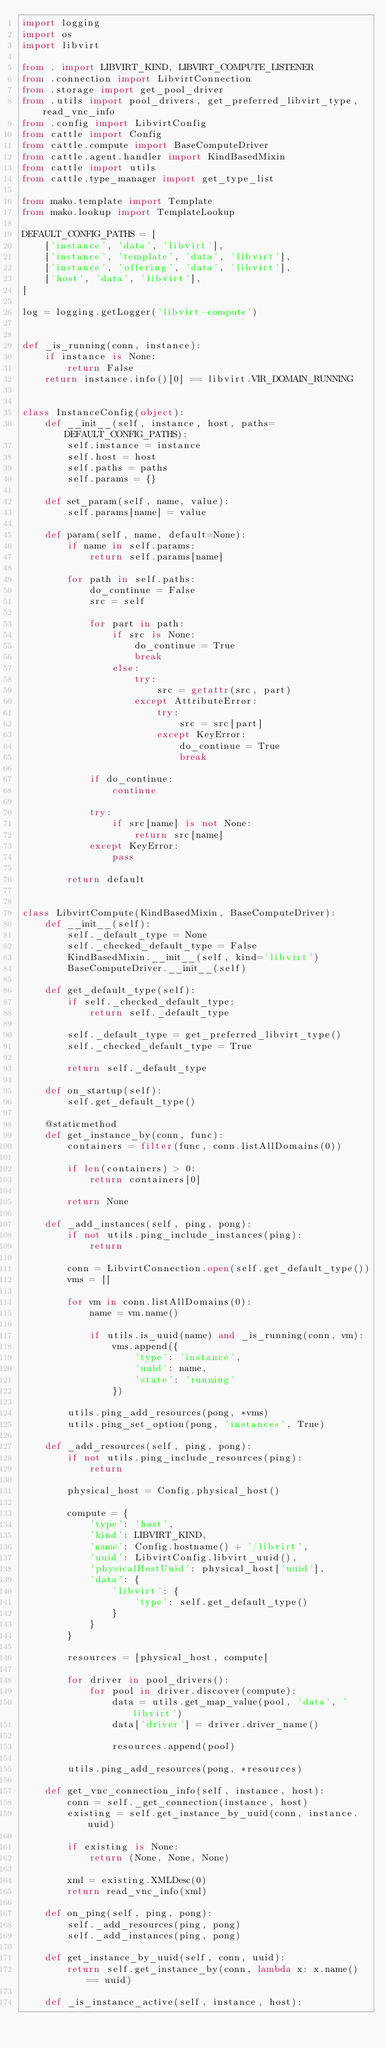<code> <loc_0><loc_0><loc_500><loc_500><_Python_>import logging
import os
import libvirt

from . import LIBVIRT_KIND, LIBVIRT_COMPUTE_LISTENER
from .connection import LibvirtConnection
from .storage import get_pool_driver
from .utils import pool_drivers, get_preferred_libvirt_type, read_vnc_info
from .config import LibvirtConfig
from cattle import Config
from cattle.compute import BaseComputeDriver
from cattle.agent.handler import KindBasedMixin
from cattle import utils
from cattle.type_manager import get_type_list

from mako.template import Template
from mako.lookup import TemplateLookup

DEFAULT_CONFIG_PATHS = [
    ['instance', 'data', 'libvirt'],
    ['instance', 'template', 'data', 'libvirt'],
    ['instance', 'offering', 'data', 'libvirt'],
    ['host', 'data', 'libvirt'],
]

log = logging.getLogger('libvirt-compute')


def _is_running(conn, instance):
    if instance is None:
        return False
    return instance.info()[0] == libvirt.VIR_DOMAIN_RUNNING


class InstanceConfig(object):
    def __init__(self, instance, host, paths=DEFAULT_CONFIG_PATHS):
        self.instance = instance
        self.host = host
        self.paths = paths
        self.params = {}

    def set_param(self, name, value):
        self.params[name] = value

    def param(self, name, default=None):
        if name in self.params:
            return self.params[name]

        for path in self.paths:
            do_continue = False
            src = self

            for part in path:
                if src is None:
                    do_continue = True
                    break
                else:
                    try:
                        src = getattr(src, part)
                    except AttributeError:
                        try:
                            src = src[part]
                        except KeyError:
                            do_continue = True
                            break

            if do_continue:
                continue

            try:
                if src[name] is not None:
                    return src[name]
            except KeyError:
                pass

        return default


class LibvirtCompute(KindBasedMixin, BaseComputeDriver):
    def __init__(self):
        self._default_type = None
        self._checked_default_type = False
        KindBasedMixin.__init__(self, kind='libvirt')
        BaseComputeDriver.__init__(self)

    def get_default_type(self):
        if self._checked_default_type:
            return self._default_type

        self._default_type = get_preferred_libvirt_type()
        self._checked_default_type = True

        return self._default_type

    def on_startup(self):
        self.get_default_type()

    @staticmethod
    def get_instance_by(conn, func):
        containers = filter(func, conn.listAllDomains(0))

        if len(containers) > 0:
            return containers[0]

        return None

    def _add_instances(self, ping, pong):
        if not utils.ping_include_instances(ping):
            return

        conn = LibvirtConnection.open(self.get_default_type())
        vms = []

        for vm in conn.listAllDomains(0):
            name = vm.name()

            if utils.is_uuid(name) and _is_running(conn, vm):
                vms.append({
                    'type': 'instance',
                    'uuid': name,
                    'state': 'running'
                })

        utils.ping_add_resources(pong, *vms)
        utils.ping_set_option(pong, 'instances', True)

    def _add_resources(self, ping, pong):
        if not utils.ping_include_resources(ping):
            return

        physical_host = Config.physical_host()

        compute = {
            'type': 'host',
            'kind': LIBVIRT_KIND,
            'name': Config.hostname() + '/libvirt',
            'uuid': LibvirtConfig.libvirt_uuid(),
            'physicalHostUuid': physical_host['uuid'],
            'data': {
                'libvirt': {
                    'type': self.get_default_type()
                }
            }
        }

        resources = [physical_host, compute]

        for driver in pool_drivers():
            for pool in driver.discover(compute):
                data = utils.get_map_value(pool, 'data', 'libvirt')
                data['driver'] = driver.driver_name()

                resources.append(pool)

        utils.ping_add_resources(pong, *resources)

    def get_vnc_connection_info(self, instance, host):
        conn = self._get_connection(instance, host)
        existing = self.get_instance_by_uuid(conn, instance.uuid)

        if existing is None:
            return (None, None, None)

        xml = existing.XMLDesc(0)
        return read_vnc_info(xml)

    def on_ping(self, ping, pong):
        self._add_resources(ping, pong)
        self._add_instances(ping, pong)

    def get_instance_by_uuid(self, conn, uuid):
        return self.get_instance_by(conn, lambda x: x.name() == uuid)

    def _is_instance_active(self, instance, host):</code> 